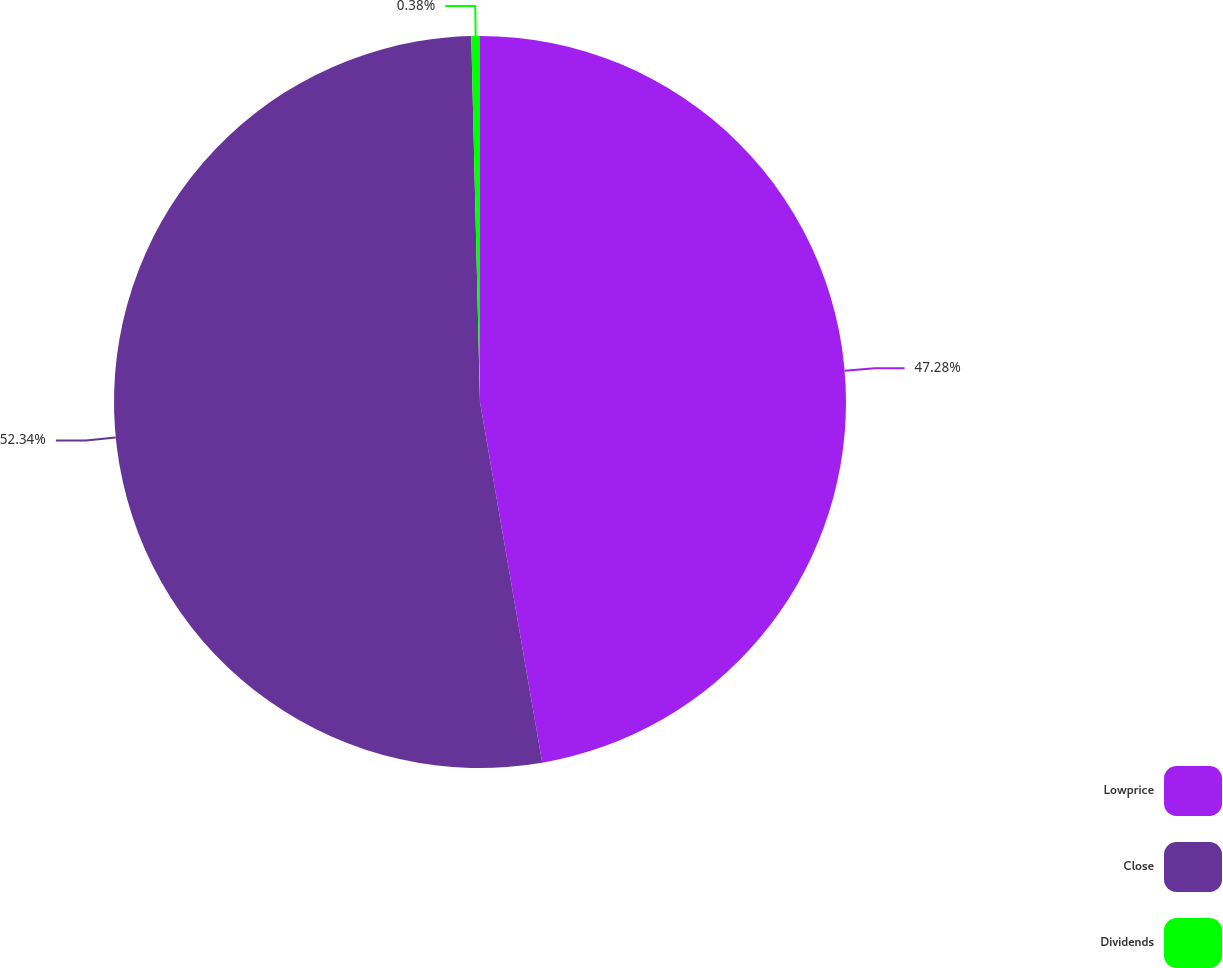Convert chart. <chart><loc_0><loc_0><loc_500><loc_500><pie_chart><fcel>Lowprice<fcel>Close<fcel>Dividends<nl><fcel>47.28%<fcel>52.34%<fcel>0.38%<nl></chart> 